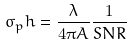<formula> <loc_0><loc_0><loc_500><loc_500>\sigma _ { p } h = \frac { \lambda } { 4 \pi A } \frac { 1 } { S N R }</formula> 